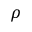<formula> <loc_0><loc_0><loc_500><loc_500>\rho</formula> 